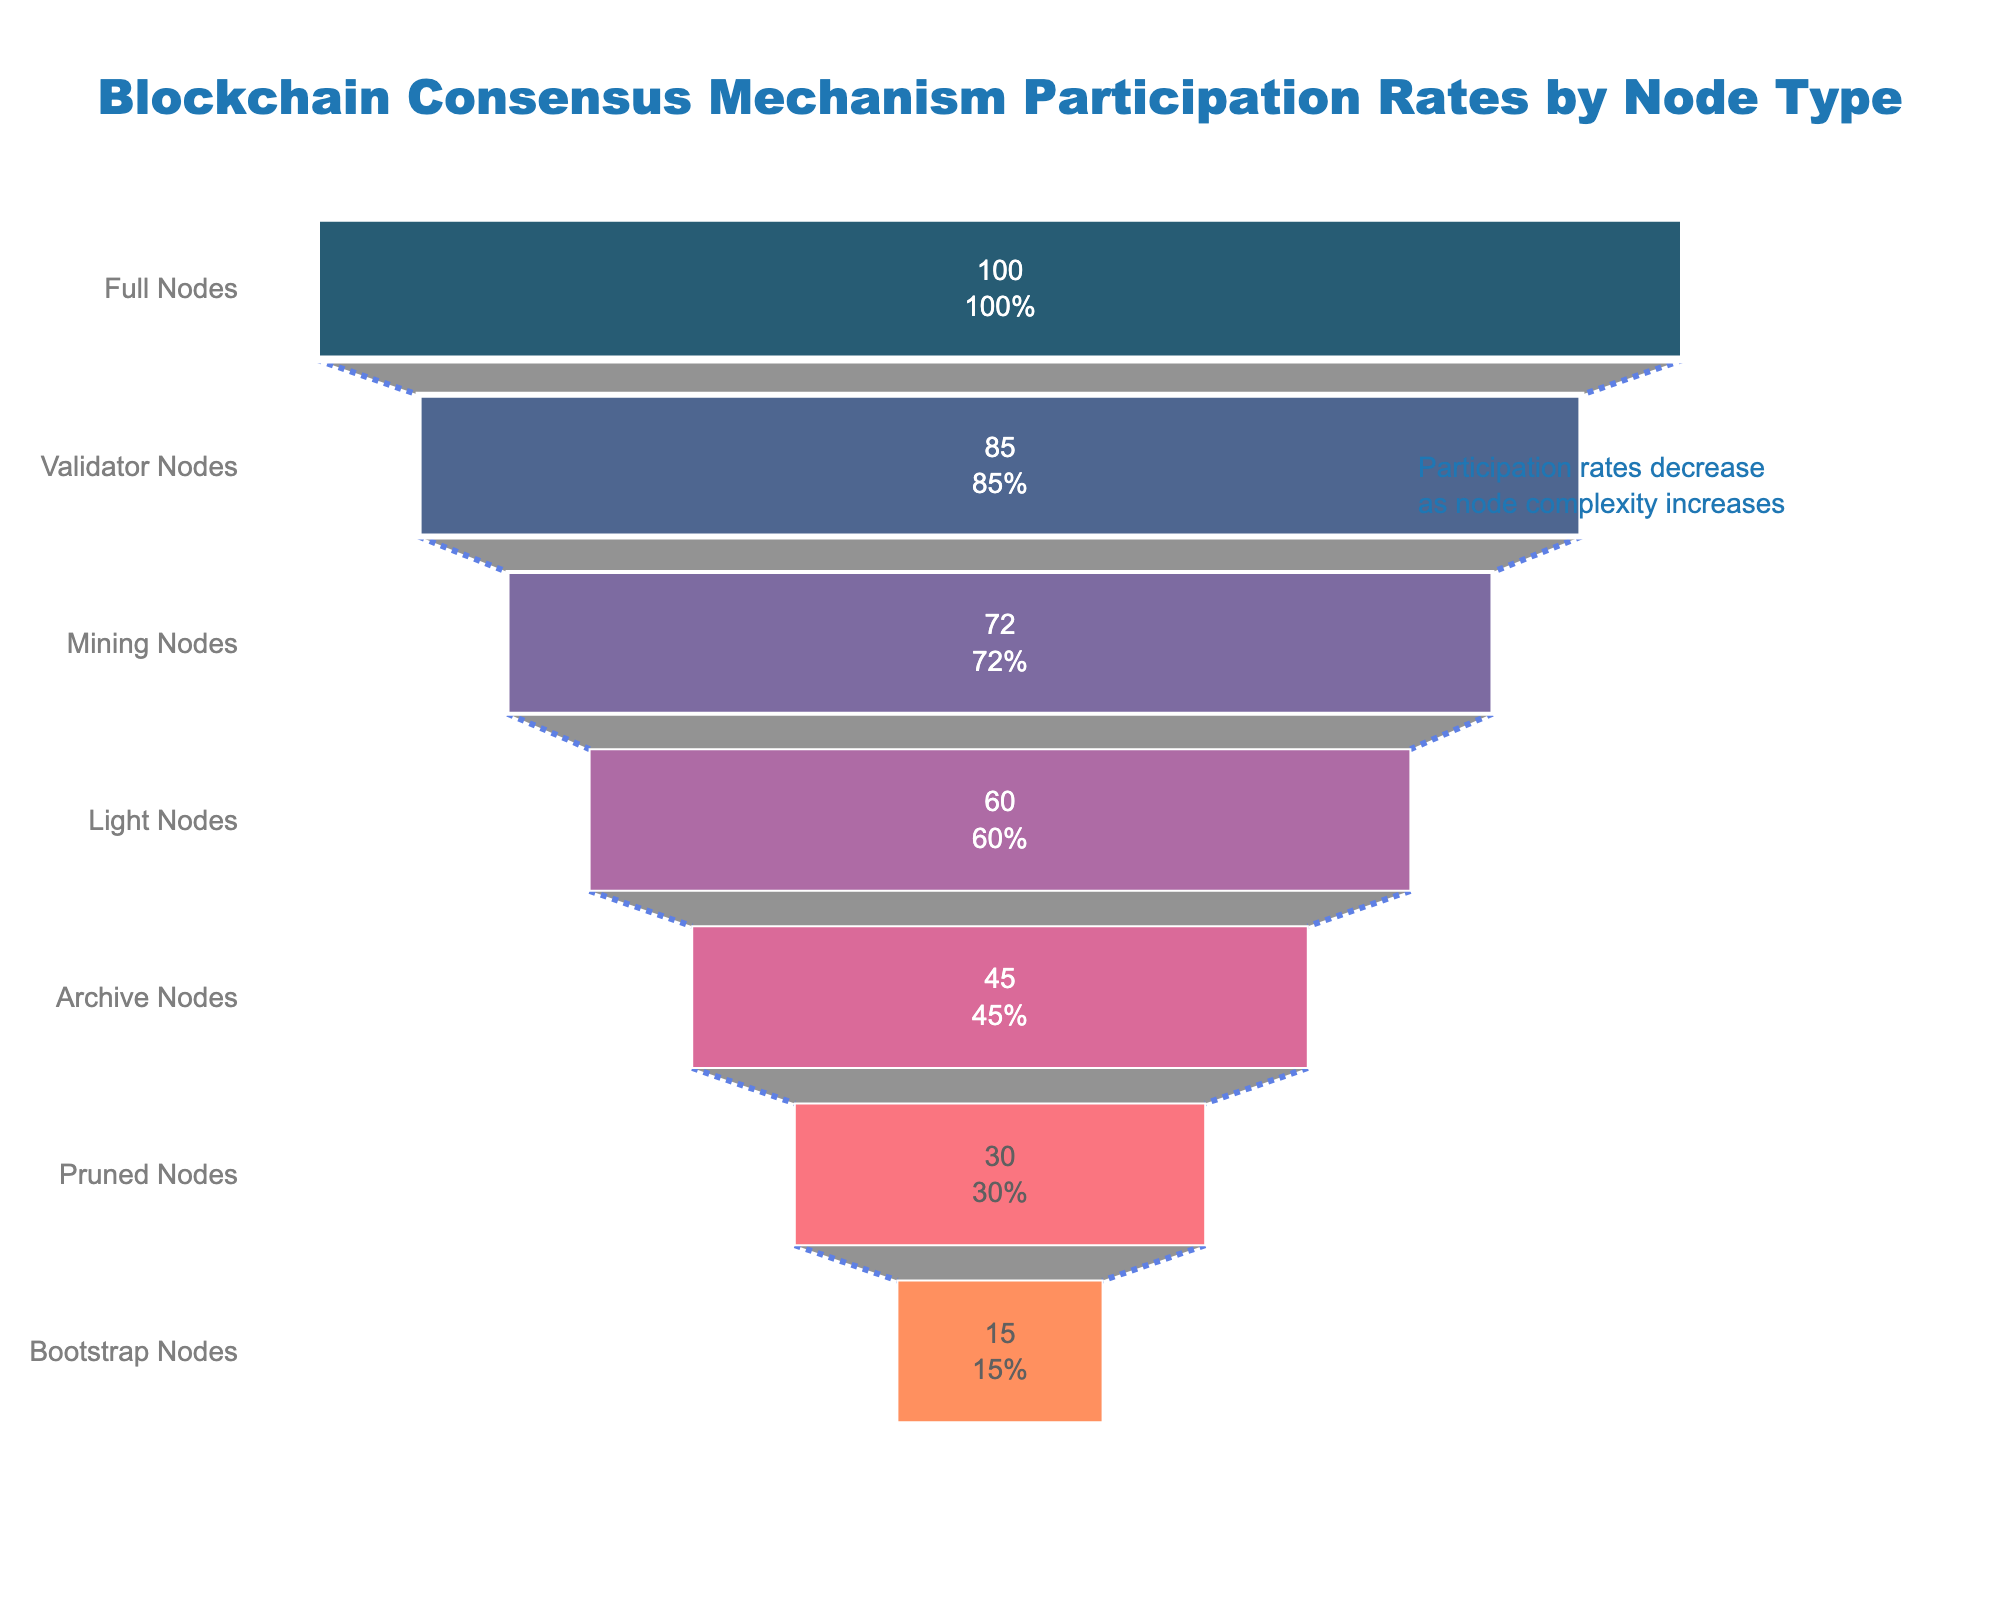Which node type has the highest participation rate? According to the funnel chart, Full Nodes are at the top, indicating that they have the highest participation rate of 100%.
Answer: Full Nodes What is the participation rate for Mining Nodes? Mining Nodes are part of the funnel chart and are listed with a participation rate of 72%.
Answer: 72% How much higher is the participation rate of Full Nodes compared to Bootstrap Nodes? Full Nodes have a participation rate of 100%, and Bootstrap Nodes have a rate of 15%. The difference is 100% - 15% = 85%.
Answer: 85% Order the node types from highest to lowest participation rate. By observing the positions on the funnel chart, we can list the node types in descending order of participation rates: Full Nodes, Validator Nodes, Mining Nodes, Light Nodes, Archive Nodes, Pruned Nodes, Bootstrap Nodes.
Answer: Full Nodes, Validator Nodes, Mining Nodes, Light Nodes, Archive Nodes, Pruned Nodes, Bootstrap Nodes What percentage of nodes have a participation rate greater than 50%? From the funnel chart, the nodes with participation rates greater than 50% are Full Nodes, Validator Nodes, Mining Nodes, and Light Nodes. There are 4 out of 7 node types, resulting in (4/7) * 100 ≈ 57.14%.
Answer: 57.14% Which node type has the third-lowest participation rate? According to their order in the funnel chart, the third-lowest participation rate node type is Archive Nodes.
Answer: Archive Nodes What is the average participation rate across all node types shown in the chart? The participation rates listed are 100%, 85%, 72%, 60%, 45%, 30%, and 15%. Summing these rates gives 407%, and the average is 407% / 7 ≈ 58.14%.
Answer: 58.14% Compare the participation rates between Validator Nodes and Light Nodes. Validator Nodes have a participation rate of 85%, while Light Nodes have a rate of 60%. Validator Nodes have a higher participation rate by 85% - 60% = 25%.
Answer: 25% What can be inferred about node complexity and participation rate from the funnel chart annotations? The annotation mentions "Participation rates decrease as node complexity increases," indicating that more complex nodes tend to have lower participation rates, as depicted by the descending order of node types in the funnel.
Answer: Participation rates decrease as node complexity increases Identify the node type with the closest participation rate to 50%. Examining the participation rates on the funnel chart, Archive Nodes have a participation rate of 45%, which is closest to 50%.
Answer: Archive Nodes 